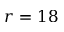<formula> <loc_0><loc_0><loc_500><loc_500>r = 1 8</formula> 